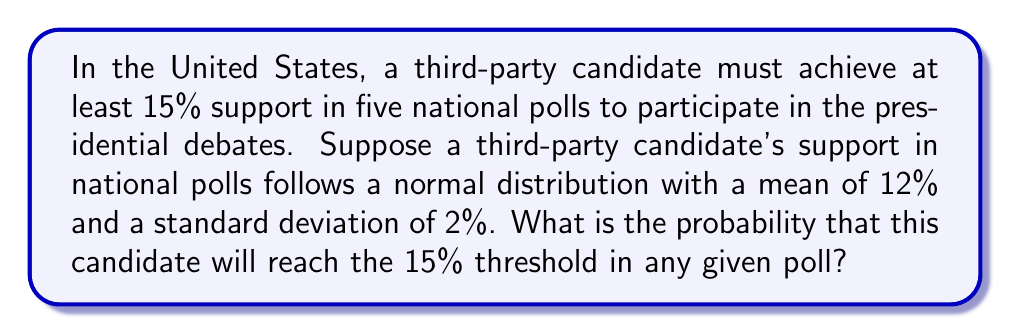Provide a solution to this math problem. To solve this problem, we need to use the properties of the normal distribution and the concept of z-scores.

1. First, let's identify the key information:
   - The threshold is 15%
   - The mean (μ) is 12%
   - The standard deviation (σ) is 2%

2. We need to calculate the z-score for the 15% threshold:

   $$ z = \frac{x - \mu}{\sigma} = \frac{15 - 12}{2} = 1.5 $$

3. Now, we need to find the probability that the candidate's support is greater than or equal to this z-score. This is equivalent to finding the area under the standard normal curve to the right of z = 1.5.

4. Using a standard normal distribution table or calculator, we can find that:

   $$ P(Z \geq 1.5) = 1 - P(Z < 1.5) = 1 - 0.9332 = 0.0668 $$

5. Convert this probability to a percentage:

   $$ 0.0668 \times 100\% = 6.68\% $$

This means that in any given poll, the third-party candidate has a 6.68% chance of reaching the 15% threshold.

To relate this to the debate participation requirement, the candidate would need to achieve this in five separate polls. Assuming the polls are independent, the probability of this happening would be even lower, calculated by raising 0.0668 to the fifth power.
Answer: The probability that the third-party candidate will reach the 15% threshold in any given poll is approximately 6.68%. 